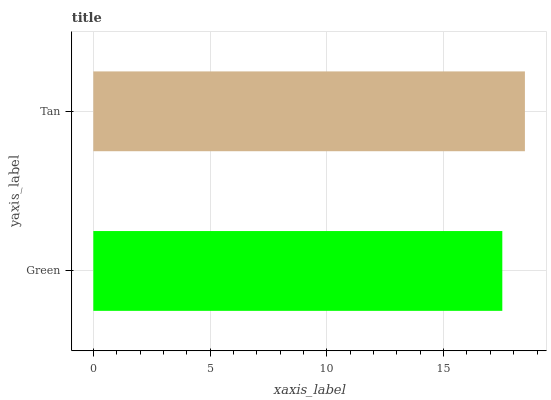Is Green the minimum?
Answer yes or no. Yes. Is Tan the maximum?
Answer yes or no. Yes. Is Tan the minimum?
Answer yes or no. No. Is Tan greater than Green?
Answer yes or no. Yes. Is Green less than Tan?
Answer yes or no. Yes. Is Green greater than Tan?
Answer yes or no. No. Is Tan less than Green?
Answer yes or no. No. Is Tan the high median?
Answer yes or no. Yes. Is Green the low median?
Answer yes or no. Yes. Is Green the high median?
Answer yes or no. No. Is Tan the low median?
Answer yes or no. No. 